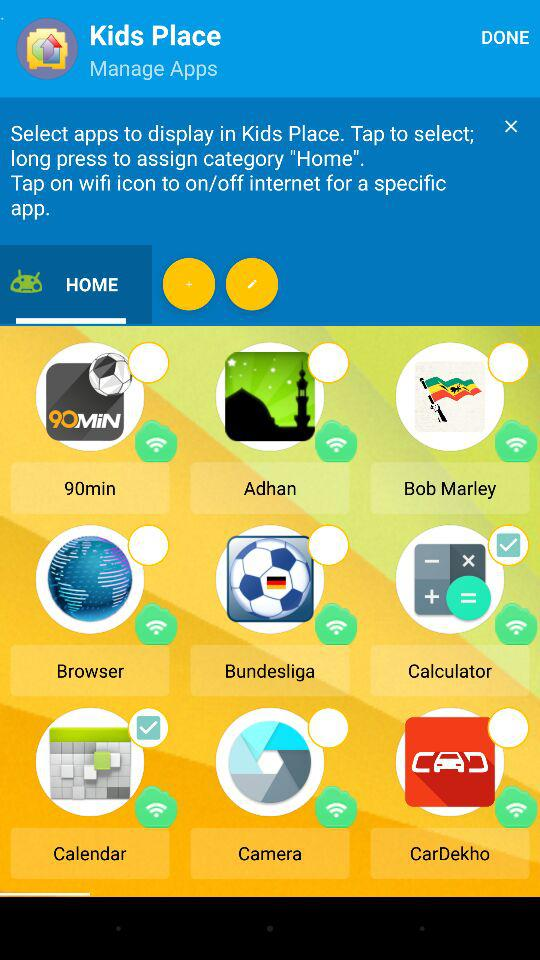What are the selected applications in the "HOME" category? The selected applications are "Calculator" and "Calendar". 